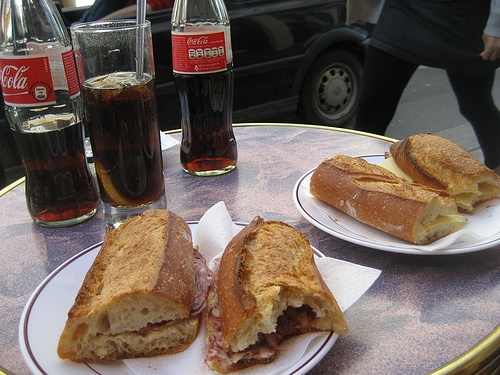Describe the objects in this image and their specific colors. I can see dining table in darkgray, lightgray, black, and gray tones, sandwich in darkgray, gray, brown, and tan tones, people in darkgray, black, and gray tones, bottle in darkgray, black, gray, and maroon tones, and car in darkgray, black, gray, and purple tones in this image. 